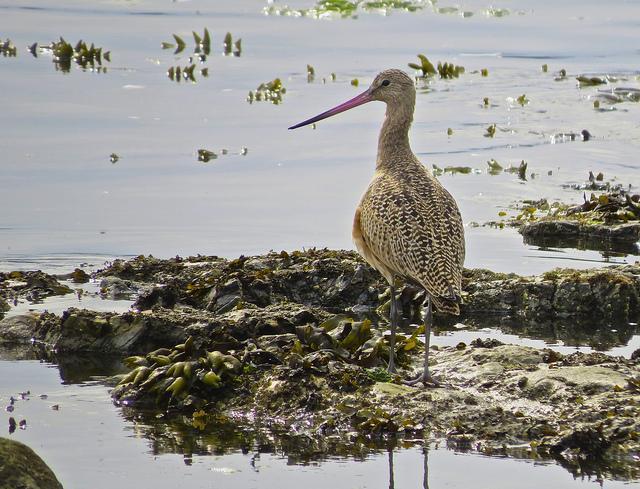How many tires are visible in between the two greyhound dog logos?
Give a very brief answer. 0. 